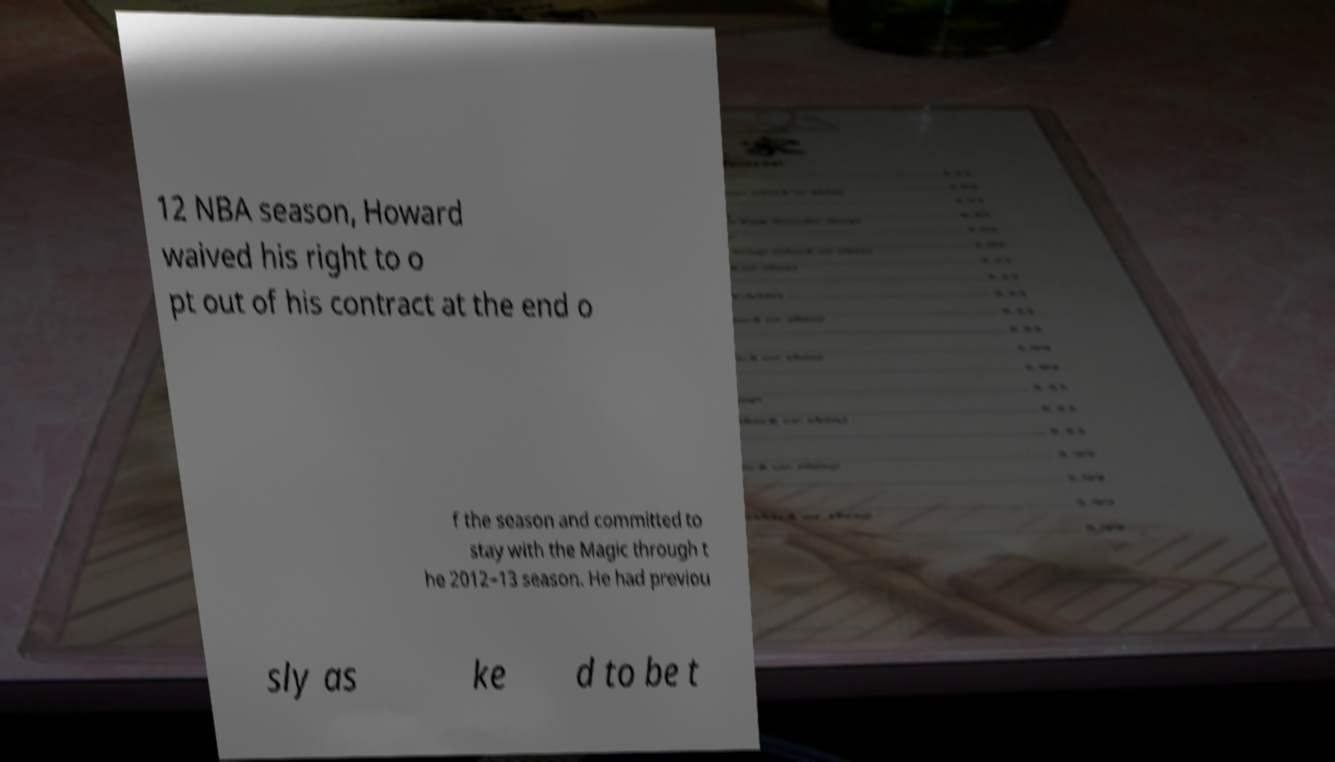Please identify and transcribe the text found in this image. 12 NBA season, Howard waived his right to o pt out of his contract at the end o f the season and committed to stay with the Magic through t he 2012–13 season. He had previou sly as ke d to be t 